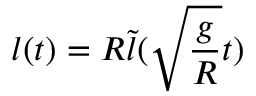<formula> <loc_0><loc_0><loc_500><loc_500>l ( t ) = R \tilde { l } ( \sqrt { \frac { g } { R } } t )</formula> 